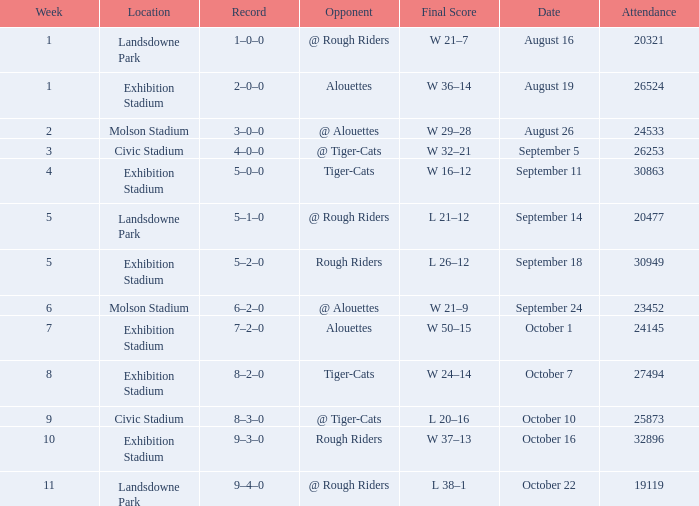How many values for attendance on the date of August 26? 1.0. 